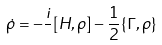Convert formula to latex. <formula><loc_0><loc_0><loc_500><loc_500>\dot { \rho } = - \frac { i } { } [ H , \rho ] - \frac { 1 } { 2 } \{ \Gamma , \rho \}</formula> 